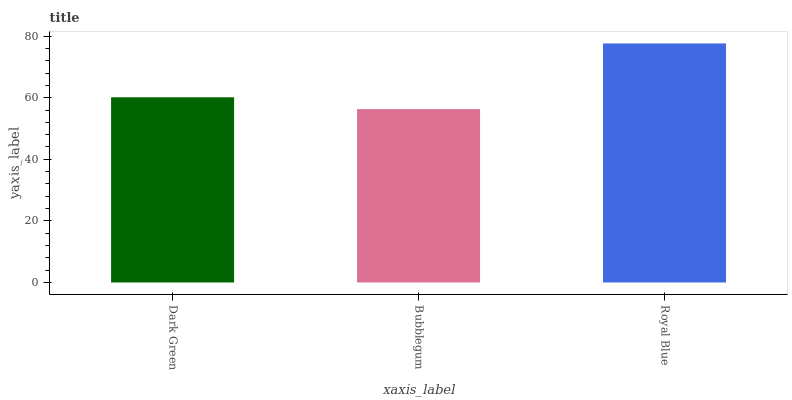Is Bubblegum the minimum?
Answer yes or no. Yes. Is Royal Blue the maximum?
Answer yes or no. Yes. Is Royal Blue the minimum?
Answer yes or no. No. Is Bubblegum the maximum?
Answer yes or no. No. Is Royal Blue greater than Bubblegum?
Answer yes or no. Yes. Is Bubblegum less than Royal Blue?
Answer yes or no. Yes. Is Bubblegum greater than Royal Blue?
Answer yes or no. No. Is Royal Blue less than Bubblegum?
Answer yes or no. No. Is Dark Green the high median?
Answer yes or no. Yes. Is Dark Green the low median?
Answer yes or no. Yes. Is Royal Blue the high median?
Answer yes or no. No. Is Royal Blue the low median?
Answer yes or no. No. 